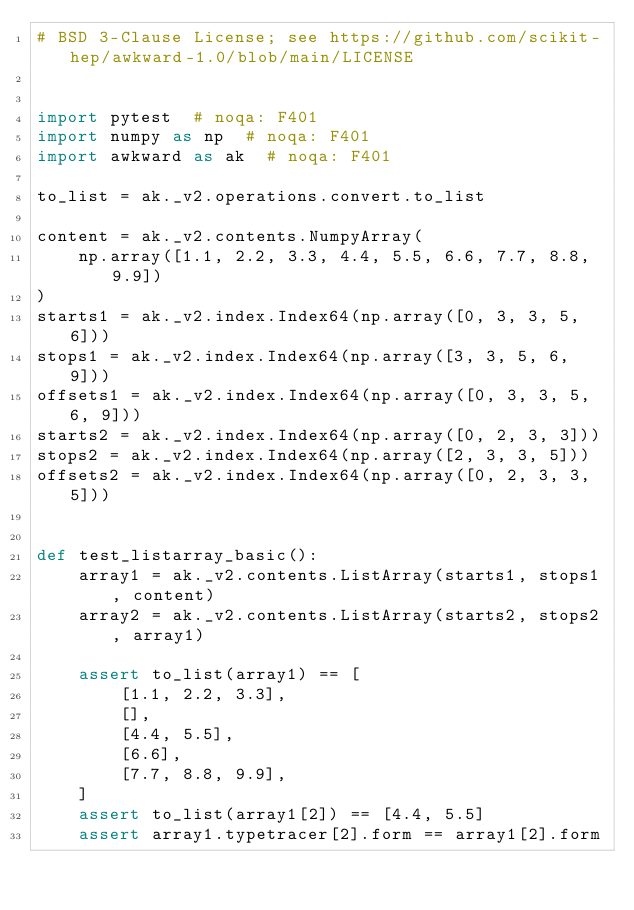Convert code to text. <code><loc_0><loc_0><loc_500><loc_500><_Python_># BSD 3-Clause License; see https://github.com/scikit-hep/awkward-1.0/blob/main/LICENSE


import pytest  # noqa: F401
import numpy as np  # noqa: F401
import awkward as ak  # noqa: F401

to_list = ak._v2.operations.convert.to_list

content = ak._v2.contents.NumpyArray(
    np.array([1.1, 2.2, 3.3, 4.4, 5.5, 6.6, 7.7, 8.8, 9.9])
)
starts1 = ak._v2.index.Index64(np.array([0, 3, 3, 5, 6]))
stops1 = ak._v2.index.Index64(np.array([3, 3, 5, 6, 9]))
offsets1 = ak._v2.index.Index64(np.array([0, 3, 3, 5, 6, 9]))
starts2 = ak._v2.index.Index64(np.array([0, 2, 3, 3]))
stops2 = ak._v2.index.Index64(np.array([2, 3, 3, 5]))
offsets2 = ak._v2.index.Index64(np.array([0, 2, 3, 3, 5]))


def test_listarray_basic():
    array1 = ak._v2.contents.ListArray(starts1, stops1, content)
    array2 = ak._v2.contents.ListArray(starts2, stops2, array1)

    assert to_list(array1) == [
        [1.1, 2.2, 3.3],
        [],
        [4.4, 5.5],
        [6.6],
        [7.7, 8.8, 9.9],
    ]
    assert to_list(array1[2]) == [4.4, 5.5]
    assert array1.typetracer[2].form == array1[2].form</code> 